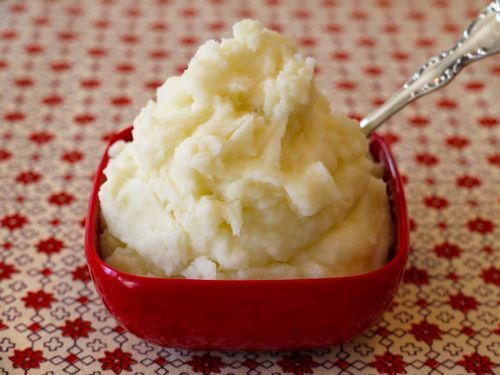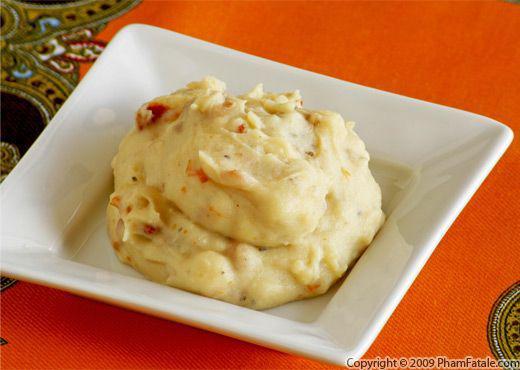The first image is the image on the left, the second image is the image on the right. For the images displayed, is the sentence "At least one image in the set features a green garnish on top of the food and other dishes in the background." factually correct? Answer yes or no. No. The first image is the image on the left, the second image is the image on the right. Given the left and right images, does the statement "A silverware serving utensil is in one image with a bowl of mashed potatoes." hold true? Answer yes or no. Yes. 